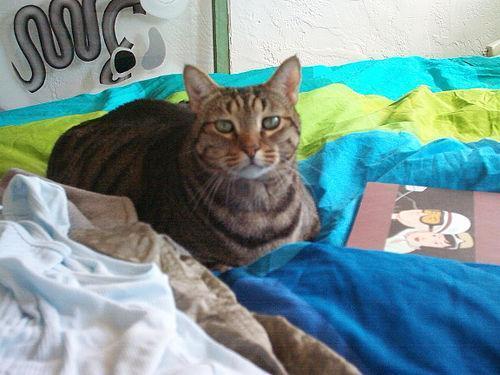How many cats are there?
Give a very brief answer. 1. 